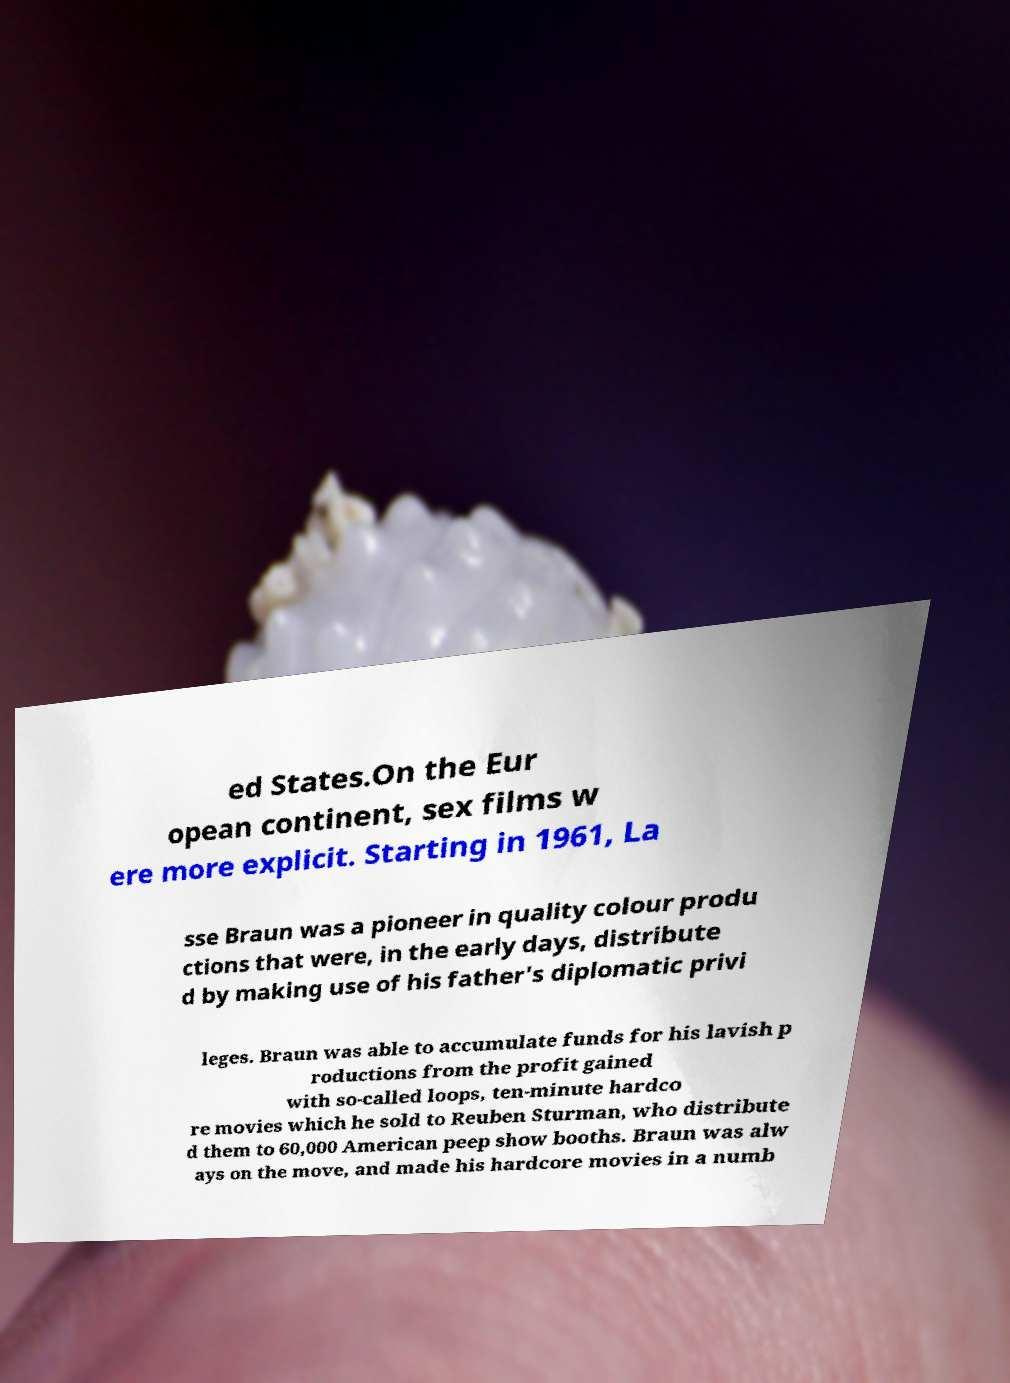Please read and relay the text visible in this image. What does it say? ed States.On the Eur opean continent, sex films w ere more explicit. Starting in 1961, La sse Braun was a pioneer in quality colour produ ctions that were, in the early days, distribute d by making use of his father's diplomatic privi leges. Braun was able to accumulate funds for his lavish p roductions from the profit gained with so-called loops, ten-minute hardco re movies which he sold to Reuben Sturman, who distribute d them to 60,000 American peep show booths. Braun was alw ays on the move, and made his hardcore movies in a numb 